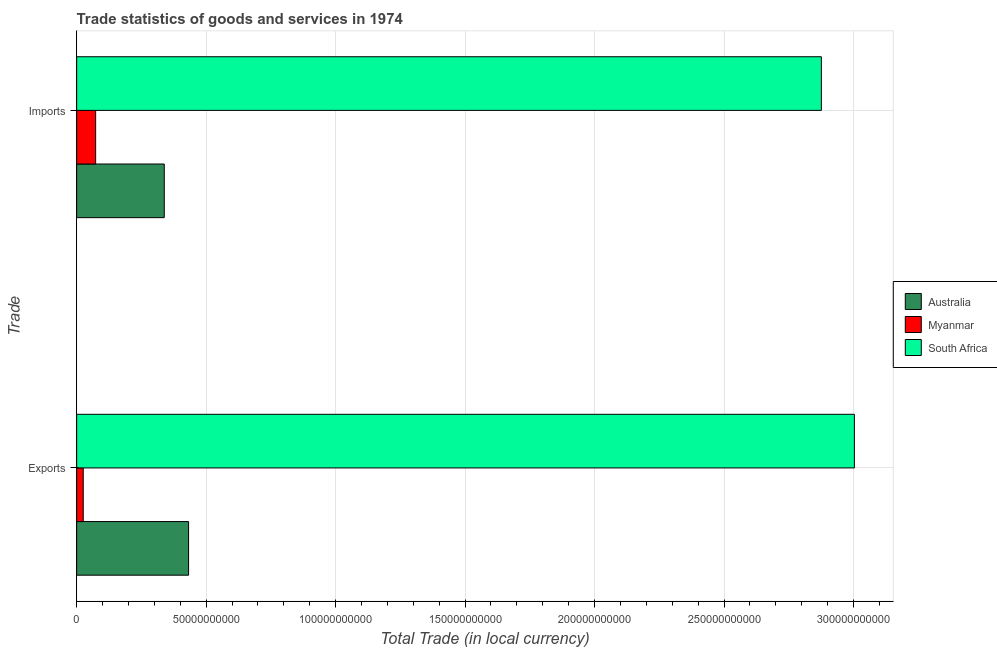How many groups of bars are there?
Keep it short and to the point. 2. Are the number of bars per tick equal to the number of legend labels?
Provide a succinct answer. Yes. Are the number of bars on each tick of the Y-axis equal?
Make the answer very short. Yes. What is the label of the 2nd group of bars from the top?
Provide a succinct answer. Exports. What is the imports of goods and services in South Africa?
Provide a short and direct response. 2.88e+11. Across all countries, what is the maximum export of goods and services?
Give a very brief answer. 3.00e+11. Across all countries, what is the minimum export of goods and services?
Keep it short and to the point. 2.54e+09. In which country was the export of goods and services maximum?
Keep it short and to the point. South Africa. In which country was the export of goods and services minimum?
Your answer should be very brief. Myanmar. What is the total export of goods and services in the graph?
Provide a succinct answer. 3.46e+11. What is the difference between the export of goods and services in Myanmar and that in South Africa?
Ensure brevity in your answer.  -2.98e+11. What is the difference between the imports of goods and services in Myanmar and the export of goods and services in South Africa?
Your response must be concise. -2.93e+11. What is the average export of goods and services per country?
Give a very brief answer. 1.15e+11. What is the difference between the export of goods and services and imports of goods and services in Australia?
Your answer should be very brief. 9.39e+09. In how many countries, is the export of goods and services greater than 160000000000 LCU?
Your answer should be very brief. 1. What is the ratio of the export of goods and services in Myanmar to that in Australia?
Offer a terse response. 0.06. What does the 2nd bar from the top in Imports represents?
Make the answer very short. Myanmar. How many countries are there in the graph?
Make the answer very short. 3. Does the graph contain any zero values?
Your answer should be very brief. No. Where does the legend appear in the graph?
Ensure brevity in your answer.  Center right. How many legend labels are there?
Give a very brief answer. 3. What is the title of the graph?
Keep it short and to the point. Trade statistics of goods and services in 1974. What is the label or title of the X-axis?
Ensure brevity in your answer.  Total Trade (in local currency). What is the label or title of the Y-axis?
Ensure brevity in your answer.  Trade. What is the Total Trade (in local currency) in Australia in Exports?
Keep it short and to the point. 4.32e+1. What is the Total Trade (in local currency) in Myanmar in Exports?
Keep it short and to the point. 2.54e+09. What is the Total Trade (in local currency) of South Africa in Exports?
Your response must be concise. 3.00e+11. What is the Total Trade (in local currency) in Australia in Imports?
Ensure brevity in your answer.  3.38e+1. What is the Total Trade (in local currency) of Myanmar in Imports?
Make the answer very short. 7.33e+09. What is the Total Trade (in local currency) in South Africa in Imports?
Offer a very short reply. 2.88e+11. Across all Trade, what is the maximum Total Trade (in local currency) in Australia?
Provide a succinct answer. 4.32e+1. Across all Trade, what is the maximum Total Trade (in local currency) in Myanmar?
Provide a succinct answer. 7.33e+09. Across all Trade, what is the maximum Total Trade (in local currency) of South Africa?
Make the answer very short. 3.00e+11. Across all Trade, what is the minimum Total Trade (in local currency) of Australia?
Ensure brevity in your answer.  3.38e+1. Across all Trade, what is the minimum Total Trade (in local currency) of Myanmar?
Keep it short and to the point. 2.54e+09. Across all Trade, what is the minimum Total Trade (in local currency) of South Africa?
Provide a succinct answer. 2.88e+11. What is the total Total Trade (in local currency) of Australia in the graph?
Offer a very short reply. 7.71e+1. What is the total Total Trade (in local currency) in Myanmar in the graph?
Your response must be concise. 9.87e+09. What is the total Total Trade (in local currency) of South Africa in the graph?
Ensure brevity in your answer.  5.88e+11. What is the difference between the Total Trade (in local currency) of Australia in Exports and that in Imports?
Your answer should be very brief. 9.39e+09. What is the difference between the Total Trade (in local currency) in Myanmar in Exports and that in Imports?
Your answer should be very brief. -4.79e+09. What is the difference between the Total Trade (in local currency) of South Africa in Exports and that in Imports?
Your response must be concise. 1.28e+1. What is the difference between the Total Trade (in local currency) in Australia in Exports and the Total Trade (in local currency) in Myanmar in Imports?
Provide a short and direct response. 3.59e+1. What is the difference between the Total Trade (in local currency) in Australia in Exports and the Total Trade (in local currency) in South Africa in Imports?
Offer a very short reply. -2.44e+11. What is the difference between the Total Trade (in local currency) of Myanmar in Exports and the Total Trade (in local currency) of South Africa in Imports?
Provide a short and direct response. -2.85e+11. What is the average Total Trade (in local currency) of Australia per Trade?
Your answer should be very brief. 3.85e+1. What is the average Total Trade (in local currency) of Myanmar per Trade?
Offer a very short reply. 4.93e+09. What is the average Total Trade (in local currency) of South Africa per Trade?
Keep it short and to the point. 2.94e+11. What is the difference between the Total Trade (in local currency) in Australia and Total Trade (in local currency) in Myanmar in Exports?
Give a very brief answer. 4.07e+1. What is the difference between the Total Trade (in local currency) of Australia and Total Trade (in local currency) of South Africa in Exports?
Provide a succinct answer. -2.57e+11. What is the difference between the Total Trade (in local currency) of Myanmar and Total Trade (in local currency) of South Africa in Exports?
Provide a succinct answer. -2.98e+11. What is the difference between the Total Trade (in local currency) of Australia and Total Trade (in local currency) of Myanmar in Imports?
Keep it short and to the point. 2.65e+1. What is the difference between the Total Trade (in local currency) in Australia and Total Trade (in local currency) in South Africa in Imports?
Provide a short and direct response. -2.54e+11. What is the difference between the Total Trade (in local currency) of Myanmar and Total Trade (in local currency) of South Africa in Imports?
Offer a terse response. -2.80e+11. What is the ratio of the Total Trade (in local currency) in Australia in Exports to that in Imports?
Provide a short and direct response. 1.28. What is the ratio of the Total Trade (in local currency) in Myanmar in Exports to that in Imports?
Make the answer very short. 0.35. What is the ratio of the Total Trade (in local currency) of South Africa in Exports to that in Imports?
Keep it short and to the point. 1.04. What is the difference between the highest and the second highest Total Trade (in local currency) of Australia?
Offer a very short reply. 9.39e+09. What is the difference between the highest and the second highest Total Trade (in local currency) in Myanmar?
Your answer should be very brief. 4.79e+09. What is the difference between the highest and the second highest Total Trade (in local currency) in South Africa?
Provide a short and direct response. 1.28e+1. What is the difference between the highest and the lowest Total Trade (in local currency) in Australia?
Your answer should be very brief. 9.39e+09. What is the difference between the highest and the lowest Total Trade (in local currency) in Myanmar?
Provide a short and direct response. 4.79e+09. What is the difference between the highest and the lowest Total Trade (in local currency) in South Africa?
Make the answer very short. 1.28e+1. 